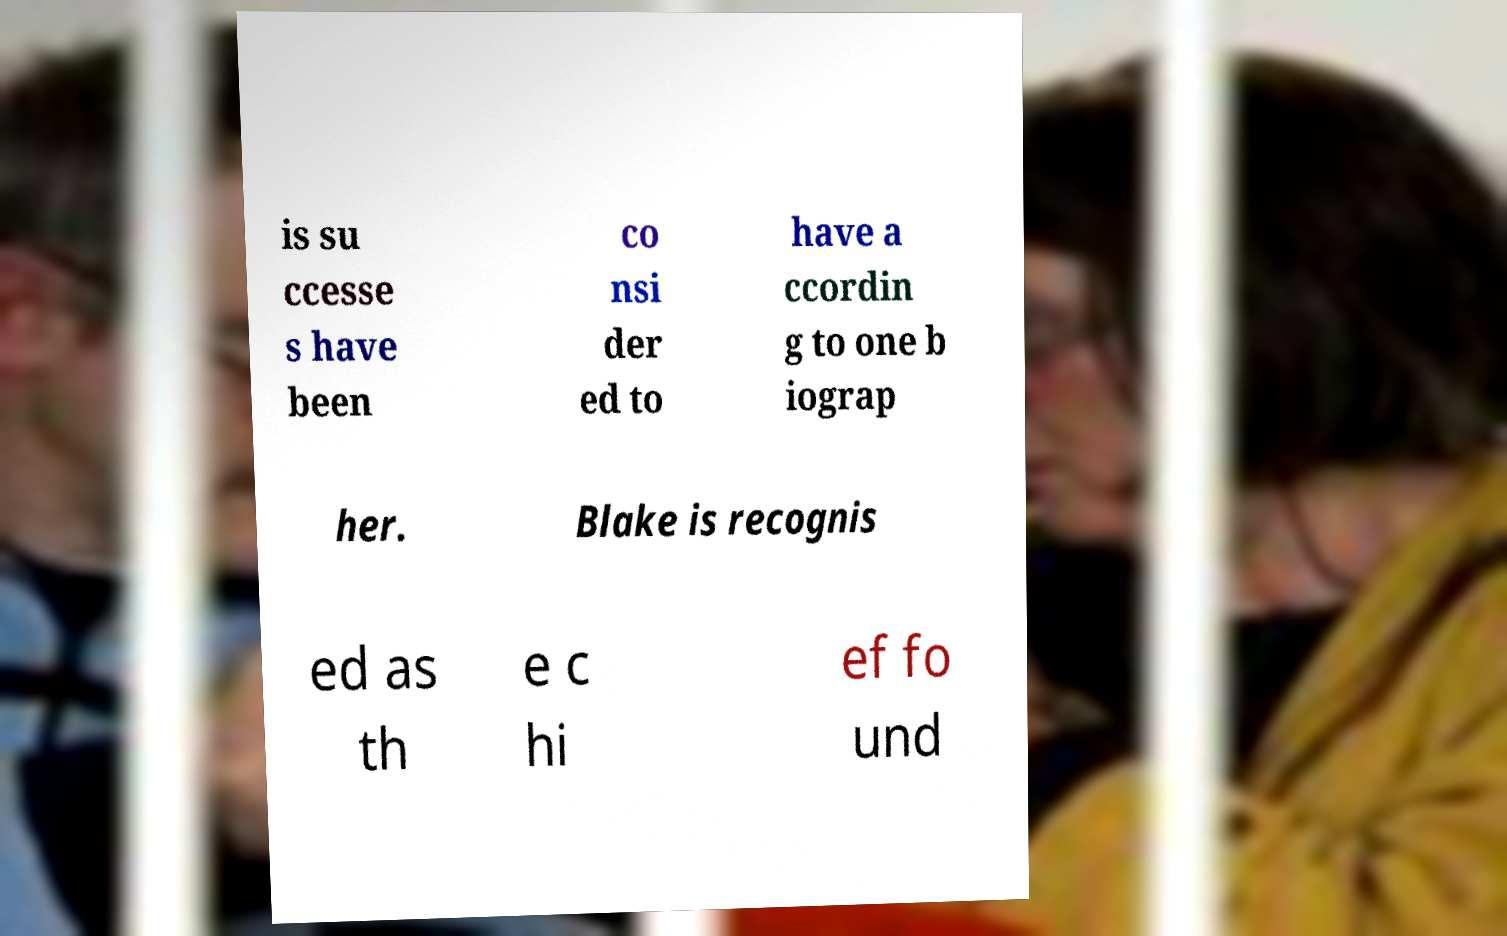Please read and relay the text visible in this image. What does it say? is su ccesse s have been co nsi der ed to have a ccordin g to one b iograp her. Blake is recognis ed as th e c hi ef fo und 